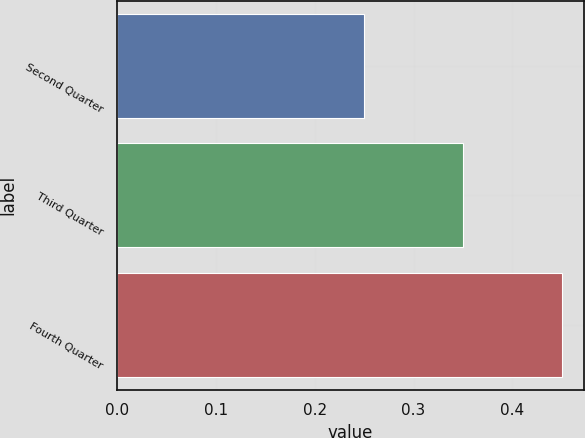Convert chart to OTSL. <chart><loc_0><loc_0><loc_500><loc_500><bar_chart><fcel>Second Quarter<fcel>Third Quarter<fcel>Fourth Quarter<nl><fcel>0.25<fcel>0.35<fcel>0.45<nl></chart> 